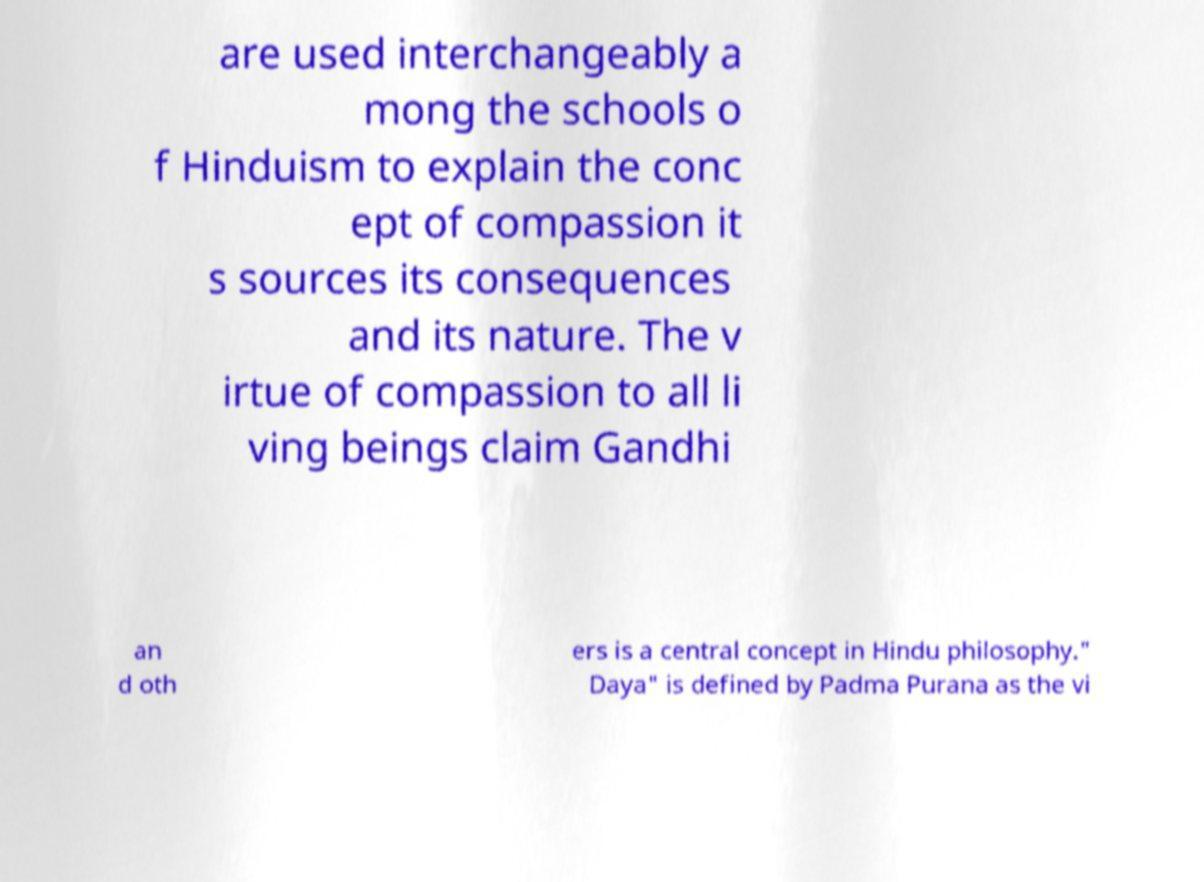There's text embedded in this image that I need extracted. Can you transcribe it verbatim? are used interchangeably a mong the schools o f Hinduism to explain the conc ept of compassion it s sources its consequences and its nature. The v irtue of compassion to all li ving beings claim Gandhi an d oth ers is a central concept in Hindu philosophy." Daya" is defined by Padma Purana as the vi 